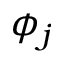<formula> <loc_0><loc_0><loc_500><loc_500>\phi _ { j }</formula> 